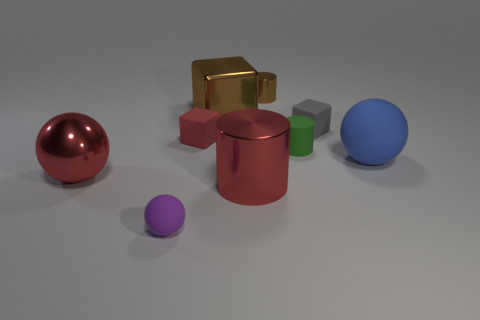Can you tell me what materials the objects might be made of based on their appearance? The objects in the image have a variety of different finishes suggesting that they could be made from various materials. The shiny red sphere and the glossy golden cubes may resemble materials like polished metals or plastic with metallic paint, while the matte surfaces of the green and grey objects could imply a ceramic or plastic material without any reflective coating. 